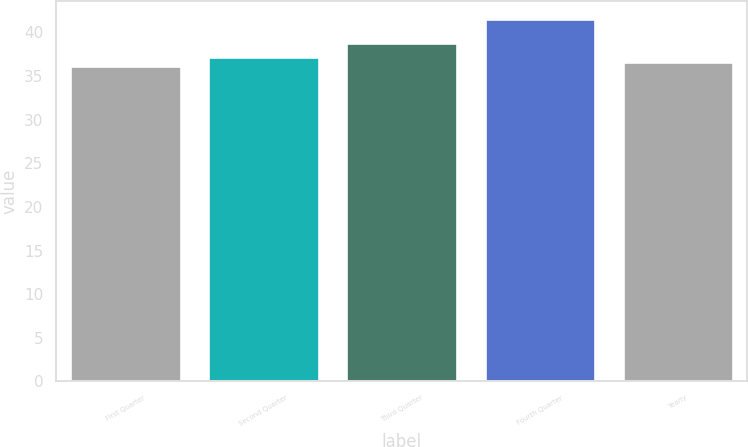<chart> <loc_0><loc_0><loc_500><loc_500><bar_chart><fcel>First Quarter<fcel>Second Quarter<fcel>Third Quarter<fcel>Fourth Quarter<fcel>Yearly<nl><fcel>36.11<fcel>37.19<fcel>38.77<fcel>41.55<fcel>36.65<nl></chart> 